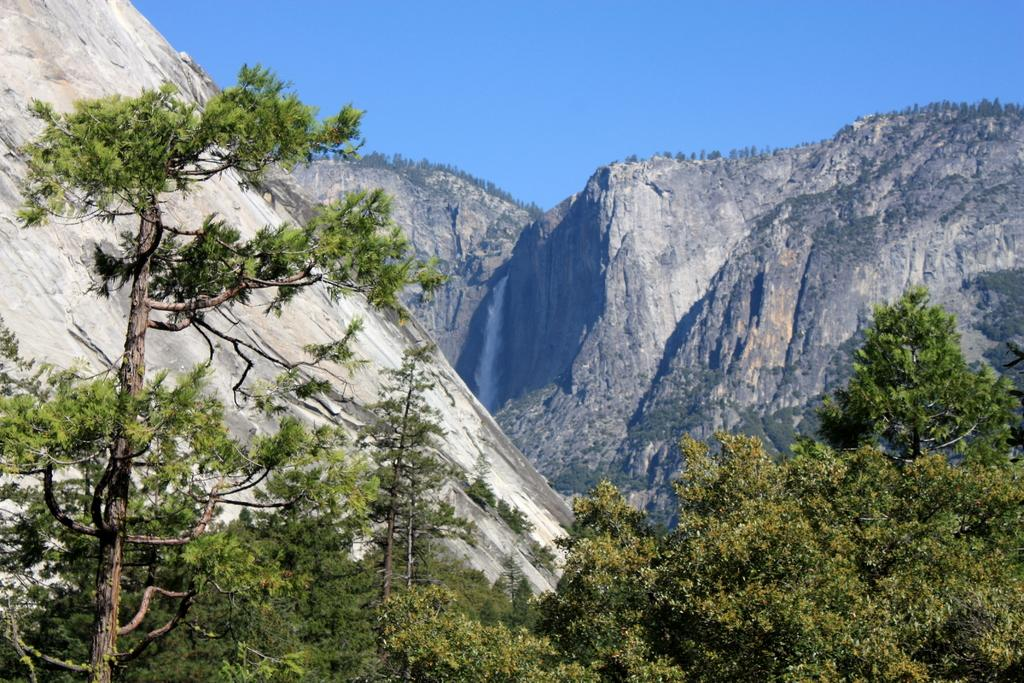What type of natural features can be seen in the image? There are trees and mountains in the image. Can you describe the trees in the image? The facts provided do not give specific details about the trees, but they are present in the image. How do the mountains appear in the image? The mountains appear in the image as part of the natural landscape. Can you see any snakes slithering through the trees in the image? There is no mention of snakes in the image, so we cannot determine if any are present. How many minutes does it take for the waves to crash against the mountains in the image? There are no waves present in the image, so we cannot determine how long it would take for them to crash against the mountains. 